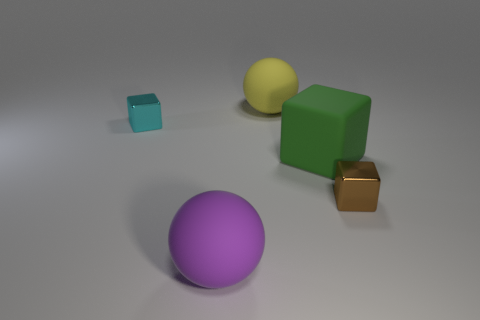What color is the other cube that is made of the same material as the tiny cyan cube?
Your answer should be compact. Brown. What is the color of the tiny cube that is on the right side of the cyan thing that is behind the big matte thing on the right side of the big yellow object?
Offer a very short reply. Brown. How many blocks are yellow rubber objects or small brown objects?
Keep it short and to the point. 1. There is a large cube; is it the same color as the tiny thing that is to the right of the rubber cube?
Make the answer very short. No. What color is the large block?
Keep it short and to the point. Green. What number of objects are either green rubber blocks or tiny blue cylinders?
Provide a short and direct response. 1. There is a brown object that is the same size as the cyan metallic object; what is its material?
Your response must be concise. Metal. What size is the sphere in front of the green rubber cube?
Offer a terse response. Large. What is the material of the brown cube?
Keep it short and to the point. Metal. What number of objects are either small metallic blocks to the right of the green object or spheres that are in front of the tiny cyan cube?
Your answer should be compact. 2. 